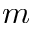<formula> <loc_0><loc_0><loc_500><loc_500>m</formula> 